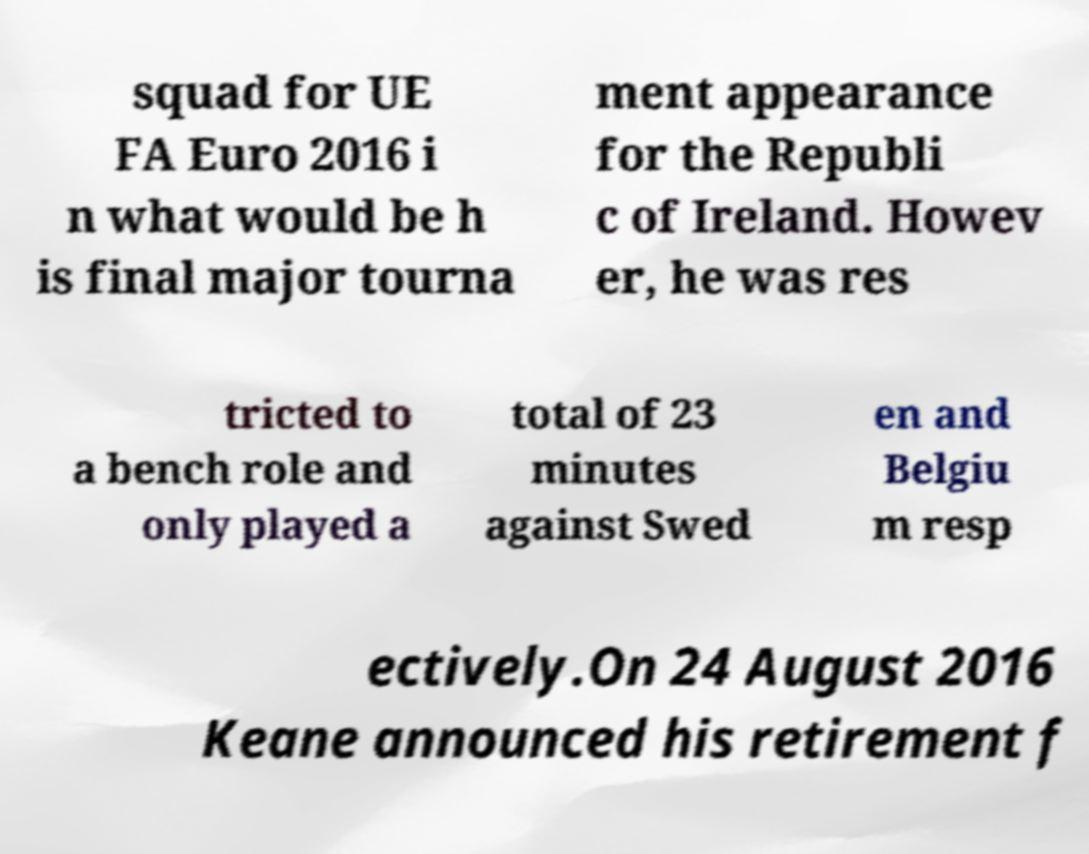Could you extract and type out the text from this image? squad for UE FA Euro 2016 i n what would be h is final major tourna ment appearance for the Republi c of Ireland. Howev er, he was res tricted to a bench role and only played a total of 23 minutes against Swed en and Belgiu m resp ectively.On 24 August 2016 Keane announced his retirement f 